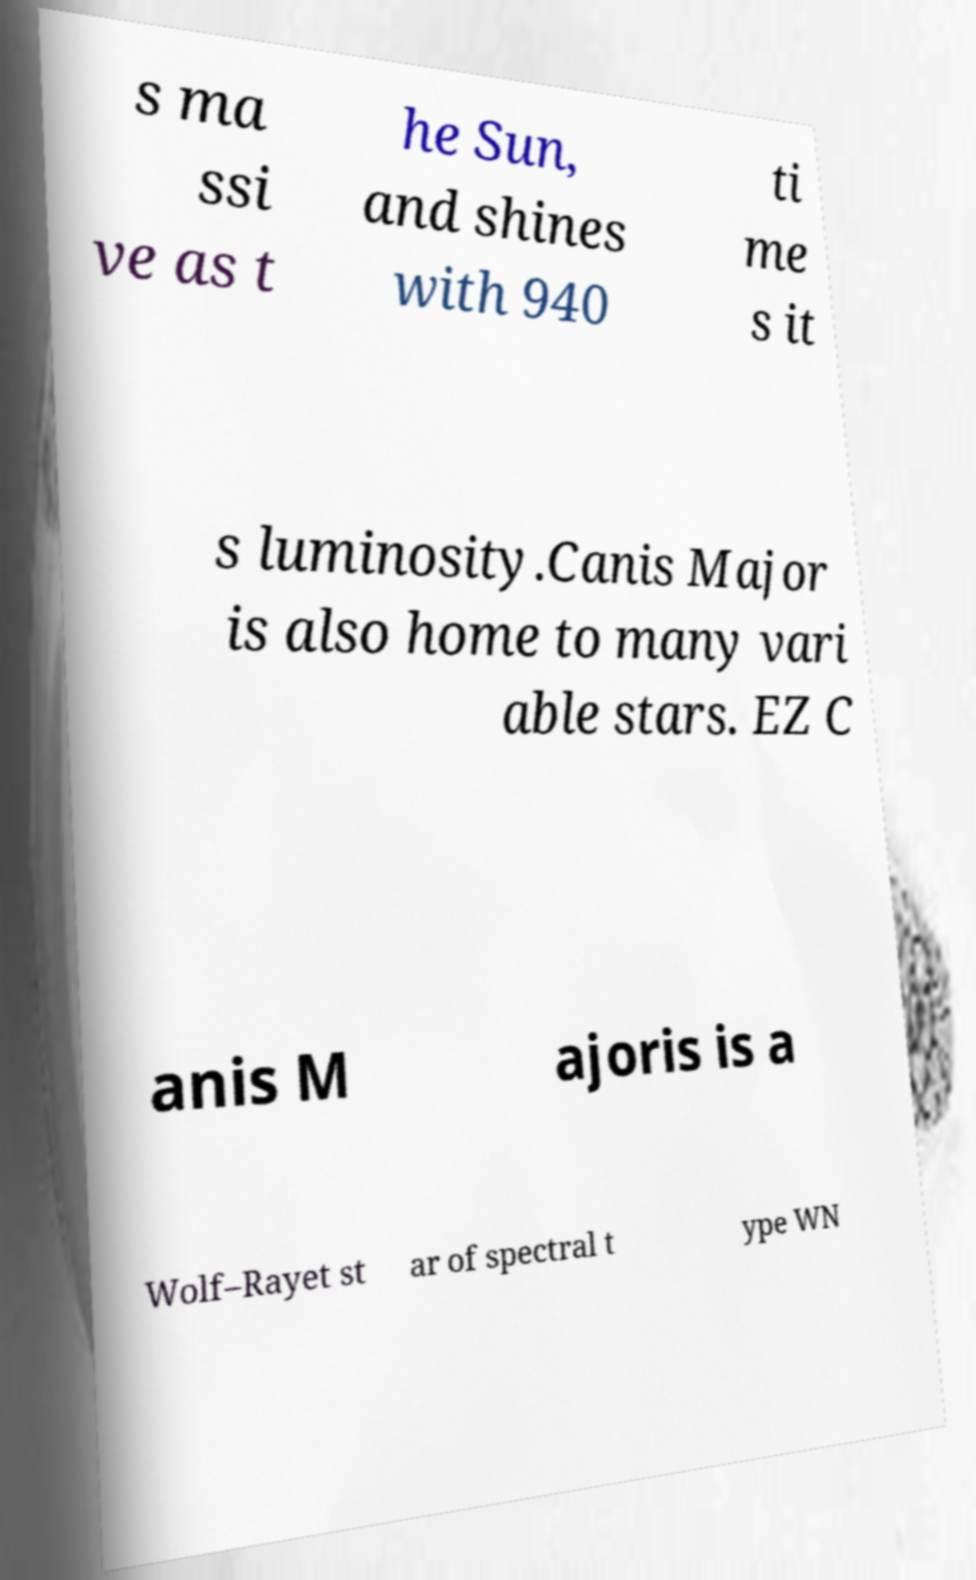There's text embedded in this image that I need extracted. Can you transcribe it verbatim? s ma ssi ve as t he Sun, and shines with 940 ti me s it s luminosity.Canis Major is also home to many vari able stars. EZ C anis M ajoris is a Wolf–Rayet st ar of spectral t ype WN 